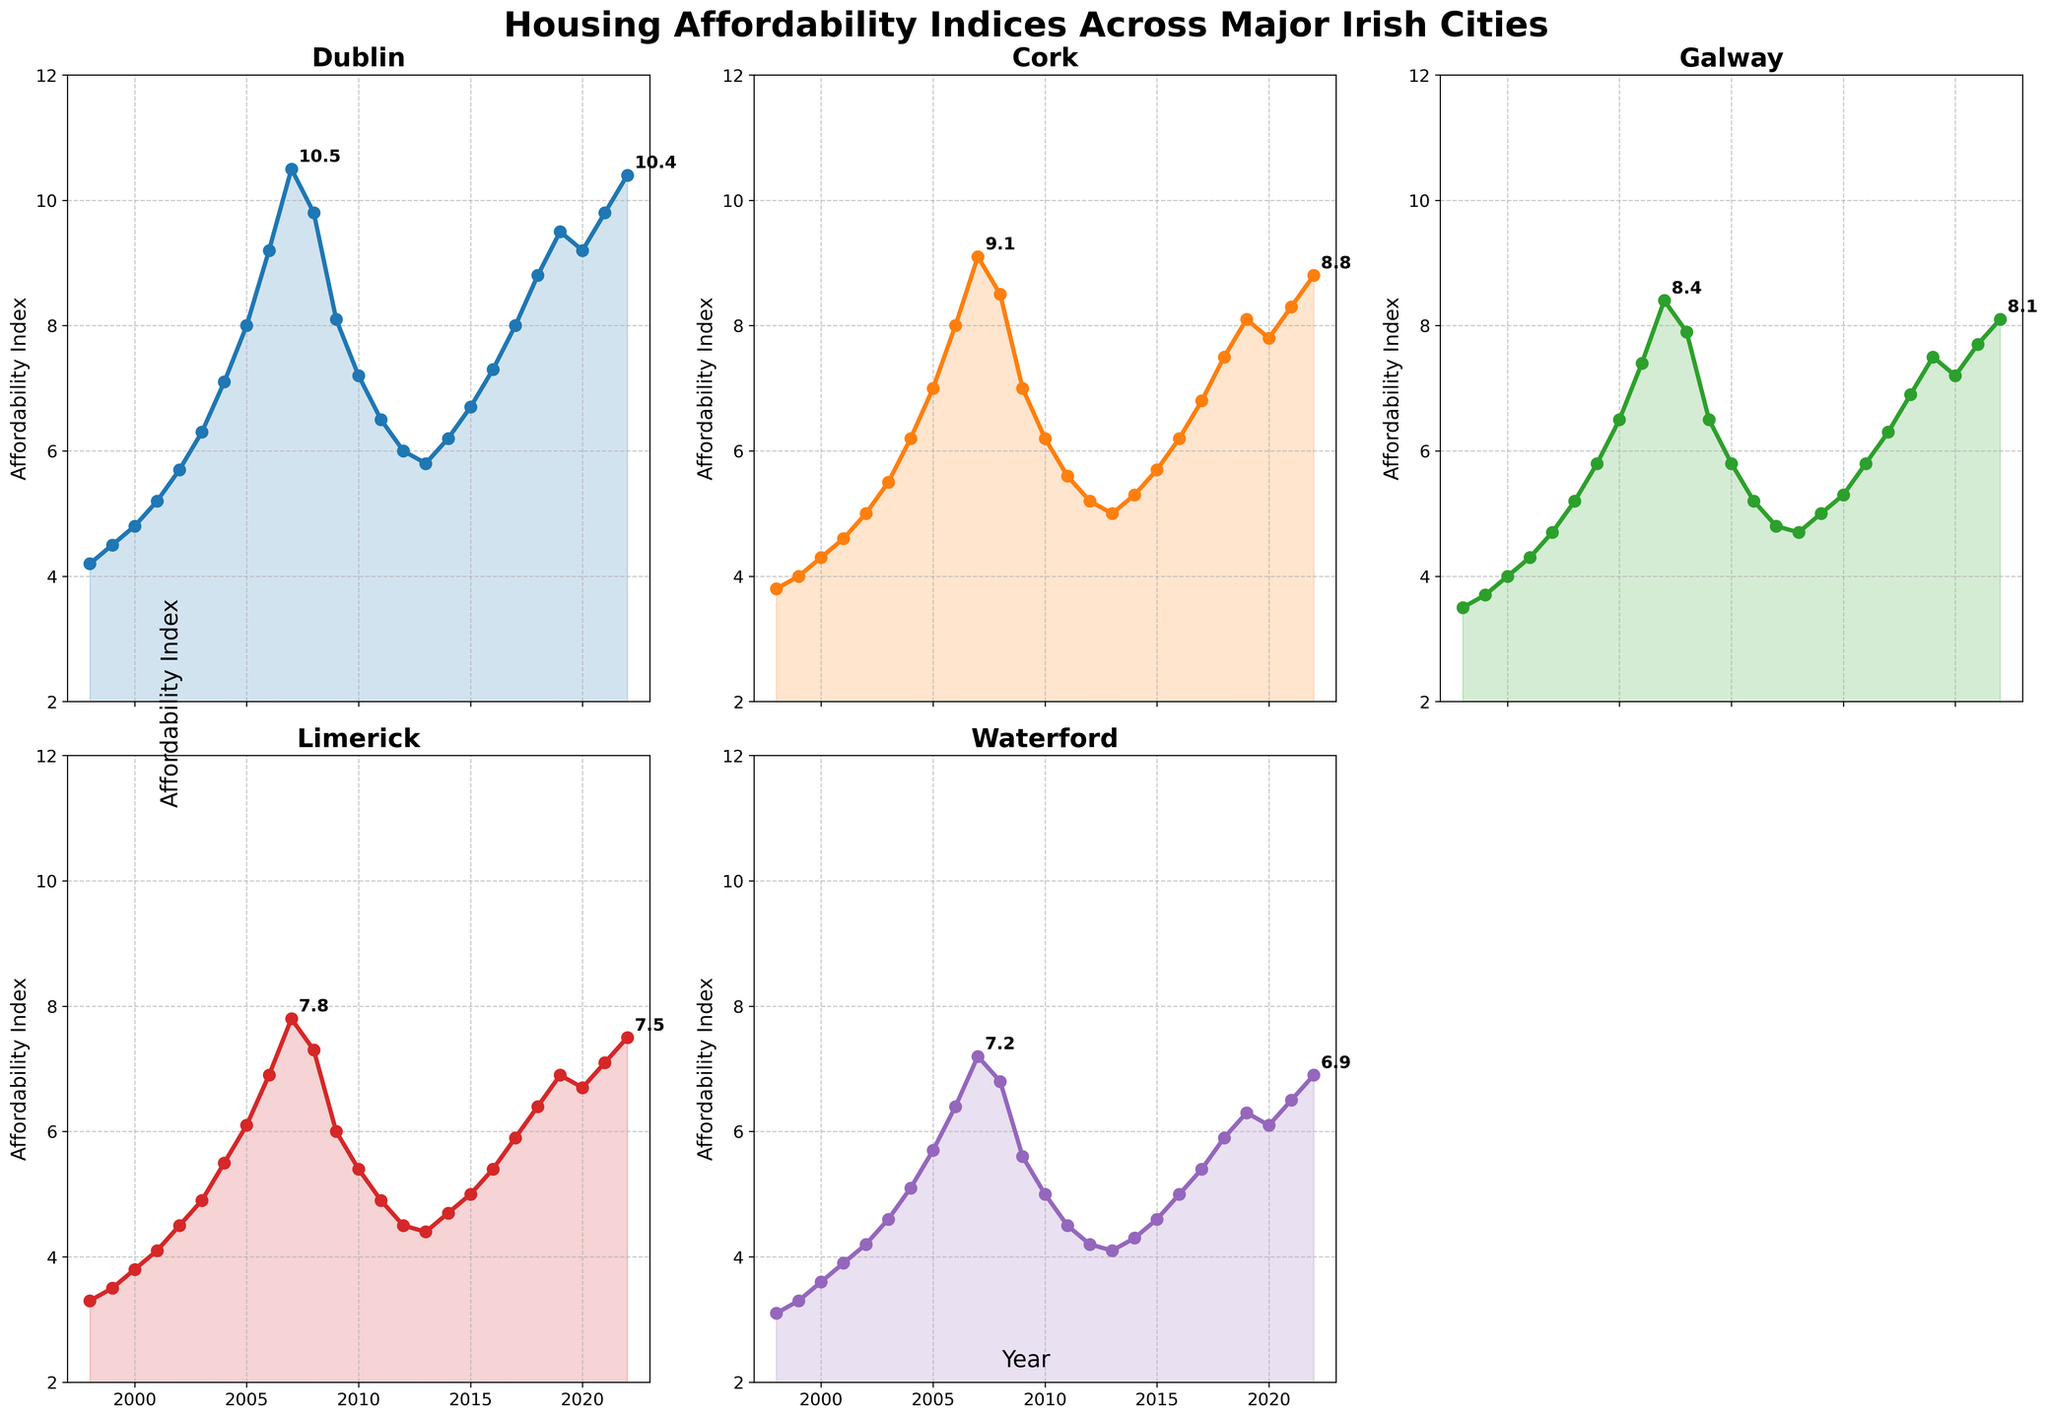What's the difference in the affordability index between Dublin and Cork in 2007? The figure shows the affordability indices for each city in 2007. For Dublin, it's 10.5, and for Cork, it's 9.1. Subtract Cork's value from Dublin's: 10.5 - 9.1 = 1.4
Answer: 1.4 Which city has the highest affordability index in 2022? By observing the plots for 2022, Dublin's index is 10.4, Cork's is 8.8, Galway's is 8.1, Limerick's is 7.5, and Waterford's is 6.9. Dublin has the highest index.
Answer: Dublin How has the affordability index in Galway changed from 2010 to 2020? In 2010, Galway's index is 5.8, and in 2020, it's 7.2. The change is calculated by 7.2 - 5.8 = 1.4
Answer: 1.4 Which city shows the largest increase in affordability index from 1998 to 2007? Calculate the increases: Dublin (10.5 - 4.2 = 6.3), Cork (9.1 - 3.8 = 5.3), Galway (8.4 - 3.5 = 4.9), Limerick (7.8 - 3.3 = 4.5), Waterford (7.2 - 3.1 = 4.1). Dublin shows the largest increase.
Answer: Dublin Which city had the lowest affordability index in 2001? Review the indices for 2001: Dublin (5.2), Cork (4.6), Galway (4.3), Limerick (4.1), Waterford (3.9). Waterford has the lowest index.
Answer: Waterford By how much did the affordability index in Limerick decrease from its peak in 2007 to its lowest point in 2012? Limerick's peak is 7.8 in 2007, and its lowest is 4.5 in 2012. So, the decrease is 7.8 - 4.5 = 3.3
Answer: 3.3 Which city had a higher affordability index in 1999, Waterford or Galway? Compare Waterford's 1999 index (3.3) with Galway's (3.7). Galway is higher.
Answer: Galway What's the average affordability index for Cork between 2010 and 2015? Indices for Cork from 2010 to 2015: 6.2, 5.6, 5.2, 5.0, 5.3, and 5.7. Calculate the average: (6.2 + 5.6 + 5.2 + 5.0 + 5.3 + 5.7) / 6 = 5.5
Answer: 5.5 From 2000 to 2009, which city experienced the most stable affordability index (smallest range)? Calculate ranges: Dublin (9.2-4.8=4.4), Cork (8.0-4.3=3.7), Galway (7.4-4.0=3.4), Limerick (6.9-3.8=3.1), Waterford (6.4-3.6=2.8). Waterford experienced the smallest range.
Answer: Waterford 